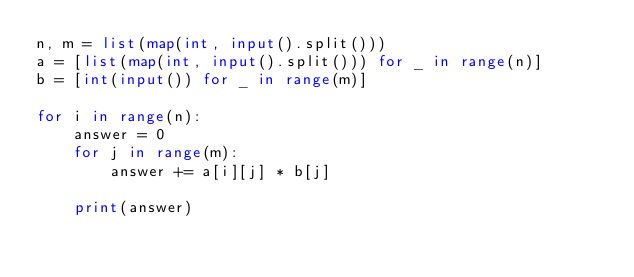<code> <loc_0><loc_0><loc_500><loc_500><_Python_>n, m = list(map(int, input().split()))
a = [list(map(int, input().split())) for _ in range(n)]
b = [int(input()) for _ in range(m)]

for i in range(n):
    answer = 0
    for j in range(m):
        answer += a[i][j] * b[j]

    print(answer)
</code> 